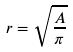<formula> <loc_0><loc_0><loc_500><loc_500>r = \sqrt { \frac { A } { \pi } }</formula> 